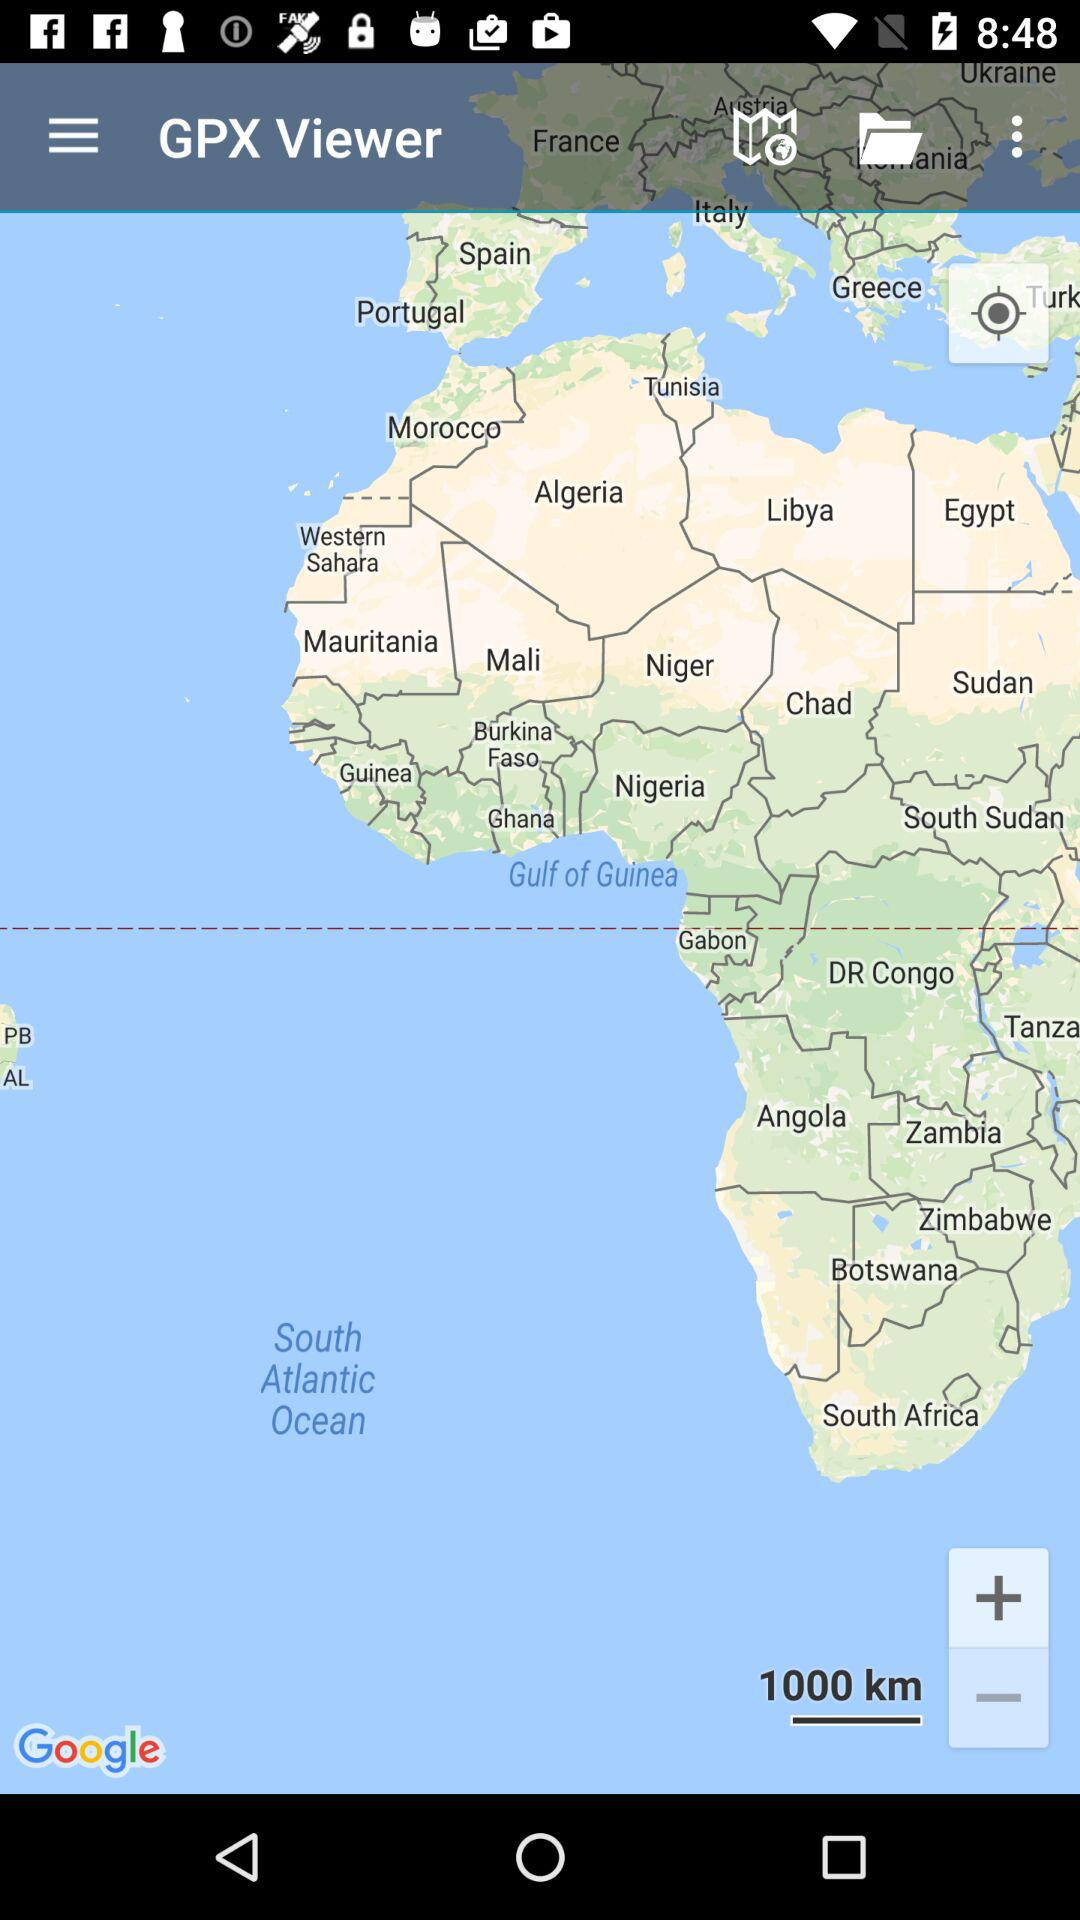What is the unit of distance? The unit of distance is kilometers. 